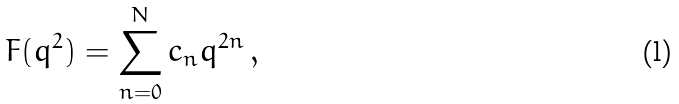Convert formula to latex. <formula><loc_0><loc_0><loc_500><loc_500>F ( q ^ { 2 } ) = \sum _ { n = 0 } ^ { N } c _ { n } q ^ { 2 n } \, ,</formula> 